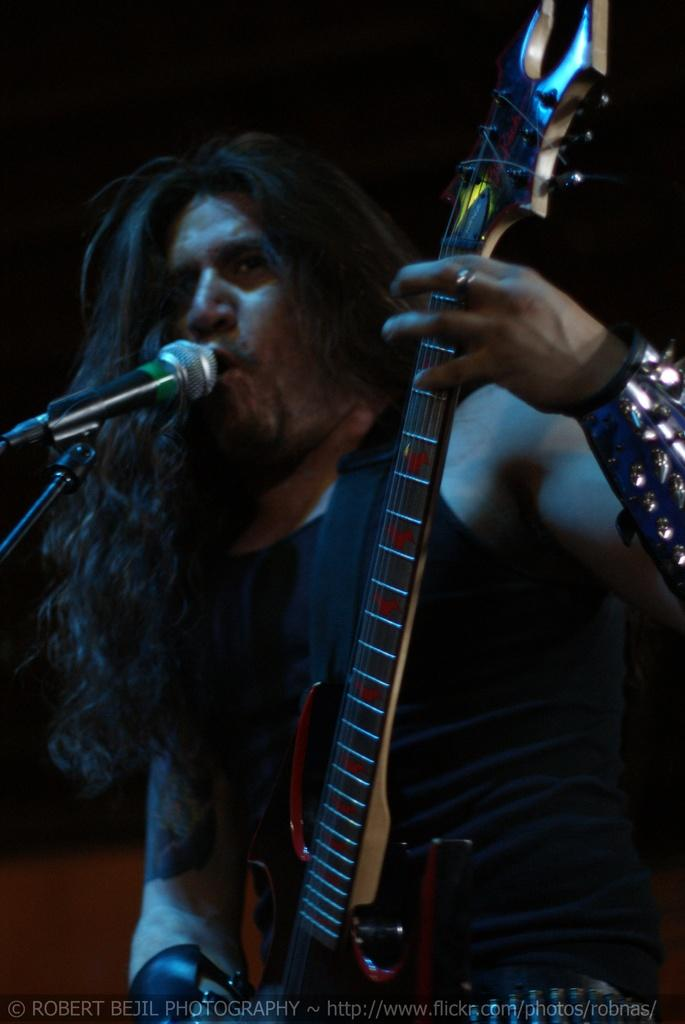What is the main subject of the image? There is a man in the image. What is the man doing in the image? The man is standing and holding a music instrument. What object is present in the image that is typically used for amplifying sound? There is a microphone in the image. What is the color of the microphone? The microphone is black in color. What is the man doing with the microphone? The man is singing into the microphone. What type of bag is the man carrying in the image? There is no bag present in the image. How does the man use the bag to enhance his performance in the image? Since there is no bag present in the image, it cannot be used to enhance his performance. 